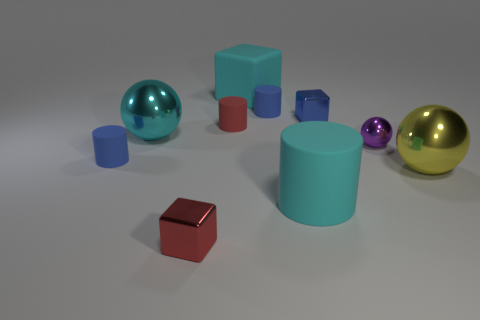Do the large rubber cylinder and the big rubber cube have the same color?
Ensure brevity in your answer.  Yes. The matte thing that is the same color as the large block is what shape?
Offer a terse response. Cylinder. There is a block that is the same color as the large rubber cylinder; what is its material?
Your response must be concise. Rubber. Is there a large matte cylinder that has the same color as the large block?
Your answer should be compact. Yes. Is there a cylinder that is right of the tiny blue rubber object that is right of the ball left of the red metal object?
Give a very brief answer. Yes. How many other objects are the same shape as the purple metal thing?
Give a very brief answer. 2. What color is the ball on the left side of the tiny cube that is in front of the big cylinder that is left of the yellow metallic thing?
Your response must be concise. Cyan. What number of things are there?
Keep it short and to the point. 10. What number of small things are either blue shiny objects or purple things?
Provide a succinct answer. 2. What shape is the red matte thing that is the same size as the blue shiny object?
Provide a short and direct response. Cylinder. 